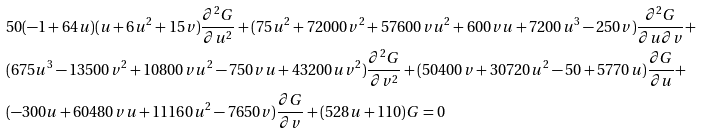Convert formula to latex. <formula><loc_0><loc_0><loc_500><loc_500>& 5 0 ( - 1 + 6 4 u ) ( u + 6 u ^ { 2 } + 1 5 v ) \frac { \partial ^ { 2 } G } { \partial u ^ { 2 } } + ( 7 5 u ^ { 2 } + 7 2 0 0 0 v ^ { 2 } + 5 7 6 0 0 v u ^ { 2 } + 6 0 0 v u + 7 2 0 0 u ^ { 3 } - 2 5 0 v ) \frac { \partial ^ { 2 } G } { \partial u \partial v } + \\ & ( 6 7 5 u ^ { 3 } - 1 3 5 0 0 v ^ { 2 } + 1 0 8 0 0 v u ^ { 2 } - 7 5 0 v u + 4 3 2 0 0 u v ^ { 2 } ) \frac { \partial ^ { 2 } G } { \partial v ^ { 2 } } + ( 5 0 4 0 0 v + 3 0 7 2 0 u ^ { 2 } - 5 0 + 5 7 7 0 u ) \frac { \partial G } { \partial u } + \\ & ( - 3 0 0 u + 6 0 4 8 0 v u + 1 1 1 6 0 u ^ { 2 } - 7 6 5 0 v ) \frac { \partial G } { \partial v } + ( 5 2 8 u + 1 1 0 ) G = 0</formula> 